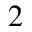<formula> <loc_0><loc_0><loc_500><loc_500>^ { 2 }</formula> 